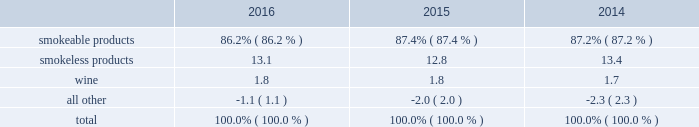The relative percentages of operating companies income ( loss ) attributable to each reportable segment and the all other category were as follows: .
For items affecting the comparability of the relative percentages of operating companies income ( loss ) attributable to each reportable segment , see note 16 .
Narrative description of business portions of the information called for by this item are included in operating results by business segment in item 7 .
Management 2019s discussion and analysis of financial condition and results of operations of this annual report on form 10-k ( 201citem 7 201d ) .
Tobacco space altria group , inc . 2019s tobacco operating companies include pm usa , usstc and other subsidiaries of ust , middleton , nu mark and nat sherman .
Altria group distribution company provides sales , distribution and consumer engagement services to altria group , inc . 2019s tobacco operating companies .
The products of altria group , inc . 2019s tobacco subsidiaries include smokeable tobacco products , consisting of cigarettes manufactured and sold by pm usa and nat sherman , machine- made large cigars and pipe tobacco manufactured and sold by middleton and premium cigars sold by nat sherman ; smokeless tobacco products manufactured and sold by usstc ; and innovative tobacco products , including e-vapor products manufactured and sold by nu mark .
Cigarettes : pm usa is the largest cigarette company in the united states , with total cigarette shipment volume in the united states of approximately 122.9 billion units in 2016 , a decrease of 2.5% ( 2.5 % ) from 2015 .
Marlboro , the principal cigarette brand of pm usa , has been the largest-selling cigarette brand in the united states for over 40 years .
Nat sherman sells substantially all of its super-premium cigarettes in the united states .
Cigars : middleton is engaged in the manufacture and sale of machine-made large cigars and pipe tobacco to customers , substantially all of which are located in the united states .
Middleton sources a portion of its cigars from an importer through a third-party contract manufacturing arrangement .
Total shipment volume for cigars was approximately 1.4 billion units in 2016 , an increase of 5.9% ( 5.9 % ) from 2015 .
Black & mild is the principal cigar brand of middleton .
Nat sherman sources its premium cigars from importers through third-party contract manufacturing arrangements and sells substantially all of its cigars in the united states .
Smokeless tobacco products : usstc is the leading producer and marketer of moist smokeless tobacco ( 201cmst 201d ) products .
The smokeless products segment includes the premium brands , copenhagen and skoal , and value brands , red seal and husky .
Substantially all of the smokeless tobacco products are manufactured and sold to customers in the united states .
Total smokeless products shipment volume was 853.5 million units in 2016 , an increase of 4.9% ( 4.9 % ) from 2015 .
Innovative tobacco products : nu mark participates in the e-vapor category and has developed and commercialized other innovative tobacco products .
In addition , nu mark sources the production of its e-vapor products through overseas contract manufacturing arrangements .
In 2013 , nu mark introduced markten e-vapor products .
In april 2014 , nu mark acquired the e-vapor business of green smoke , inc .
And its affiliates ( 201cgreen smoke 201d ) , which began selling e-vapor products in 2009 .
For a further discussion of the acquisition of green smoke , see note 3 .
Acquisition of green smoke to the consolidated financial statements in item 8 ( 201cnote 3 201d ) .
In december 2013 , altria group , inc . 2019s subsidiaries entered into a series of agreements with philip morris international inc .
( 201cpmi 201d ) pursuant to which altria group , inc . 2019s subsidiaries provide an exclusive license to pmi to sell nu mark 2019s e-vapor products outside the united states , and pmi 2019s subsidiaries provide an exclusive license to altria group , inc . 2019s subsidiaries to sell two of pmi 2019s heated tobacco product platforms in the united states .
Further , in july 2015 , altria group , inc .
Announced the expansion of its strategic framework with pmi to include a joint research , development and technology-sharing agreement .
Under this agreement , altria group , inc . 2019s subsidiaries and pmi will collaborate to develop e-vapor products for commercialization in the united states by altria group , inc . 2019s subsidiaries and in markets outside the united states by pmi .
This agreement also provides for exclusive technology cross licenses , technical information sharing and cooperation on scientific assessment , regulatory engagement and approval related to e-vapor products .
In the fourth quarter of 2016 , pmi submitted a modified risk tobacco product ( 201cmrtp 201d ) application for an electronically heated tobacco product with the united states food and drug administration 2019s ( 201cfda 201d ) center for tobacco products and announced that it plans to file its corresponding pre-market tobacco product application during the first quarter of 2017 .
The fda must determine whether to accept the applications for substantive review .
Upon regulatory authorization by the fda , altria group , inc . 2019s subsidiaries will have an exclusive license to sell this heated tobacco product in the united states .
Distribution , competition and raw materials : altria group , inc . 2019s tobacco subsidiaries sell their tobacco products principally to wholesalers ( including distributors ) , large retail organizations , including chain stores , and the armed services .
The market for tobacco products is highly competitive , characterized by brand recognition and loyalty , with product quality , taste , price , product innovation , marketing , packaging and distribution constituting the significant methods of competition .
Promotional activities include , in certain instances and where .
What is the total units of shipment volume for cigars in 2015 , in billions? 
Computations: (1.4 / (100 + 5.9%))
Answer: 0.01399. 